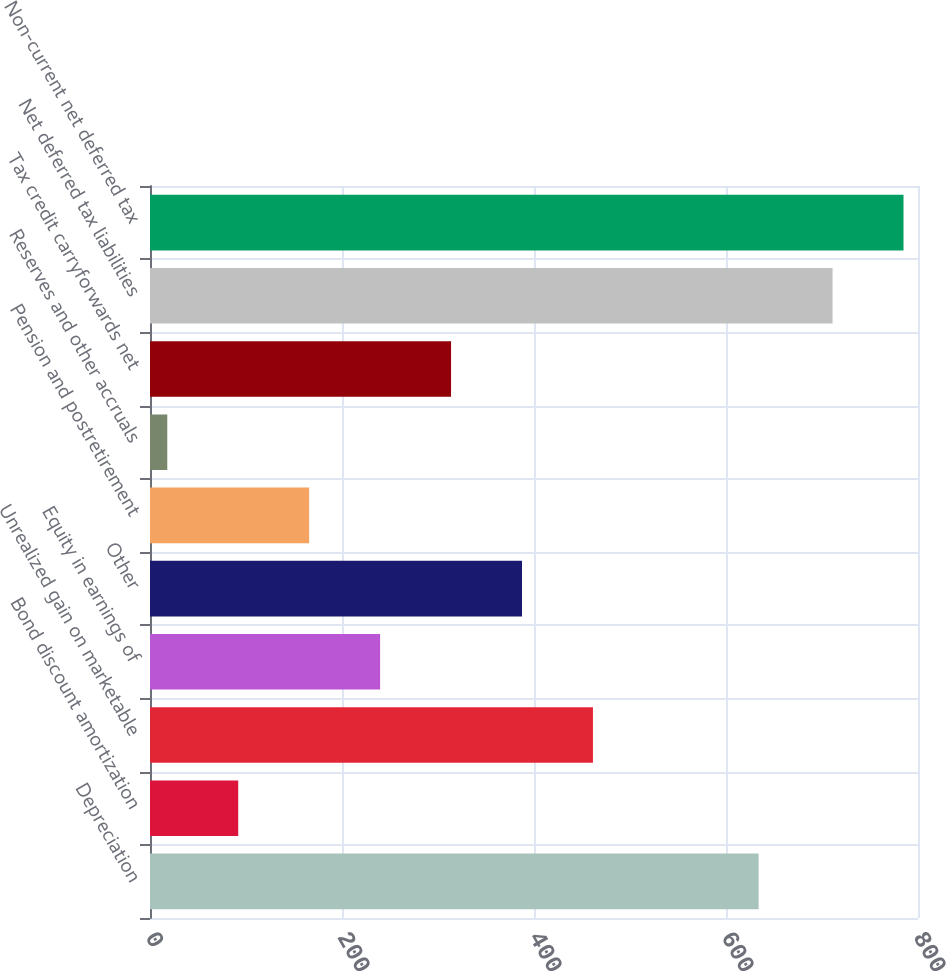Convert chart. <chart><loc_0><loc_0><loc_500><loc_500><bar_chart><fcel>Depreciation<fcel>Bond discount amortization<fcel>Unrealized gain on marketable<fcel>Equity in earnings of<fcel>Other<fcel>Pension and postretirement<fcel>Reserves and other accruals<fcel>Tax credit carryforwards net<fcel>Net deferred tax liabilities<fcel>Non-current net deferred tax<nl><fcel>634<fcel>91.9<fcel>461.4<fcel>239.7<fcel>387.5<fcel>165.8<fcel>18<fcel>313.6<fcel>711<fcel>784.9<nl></chart> 